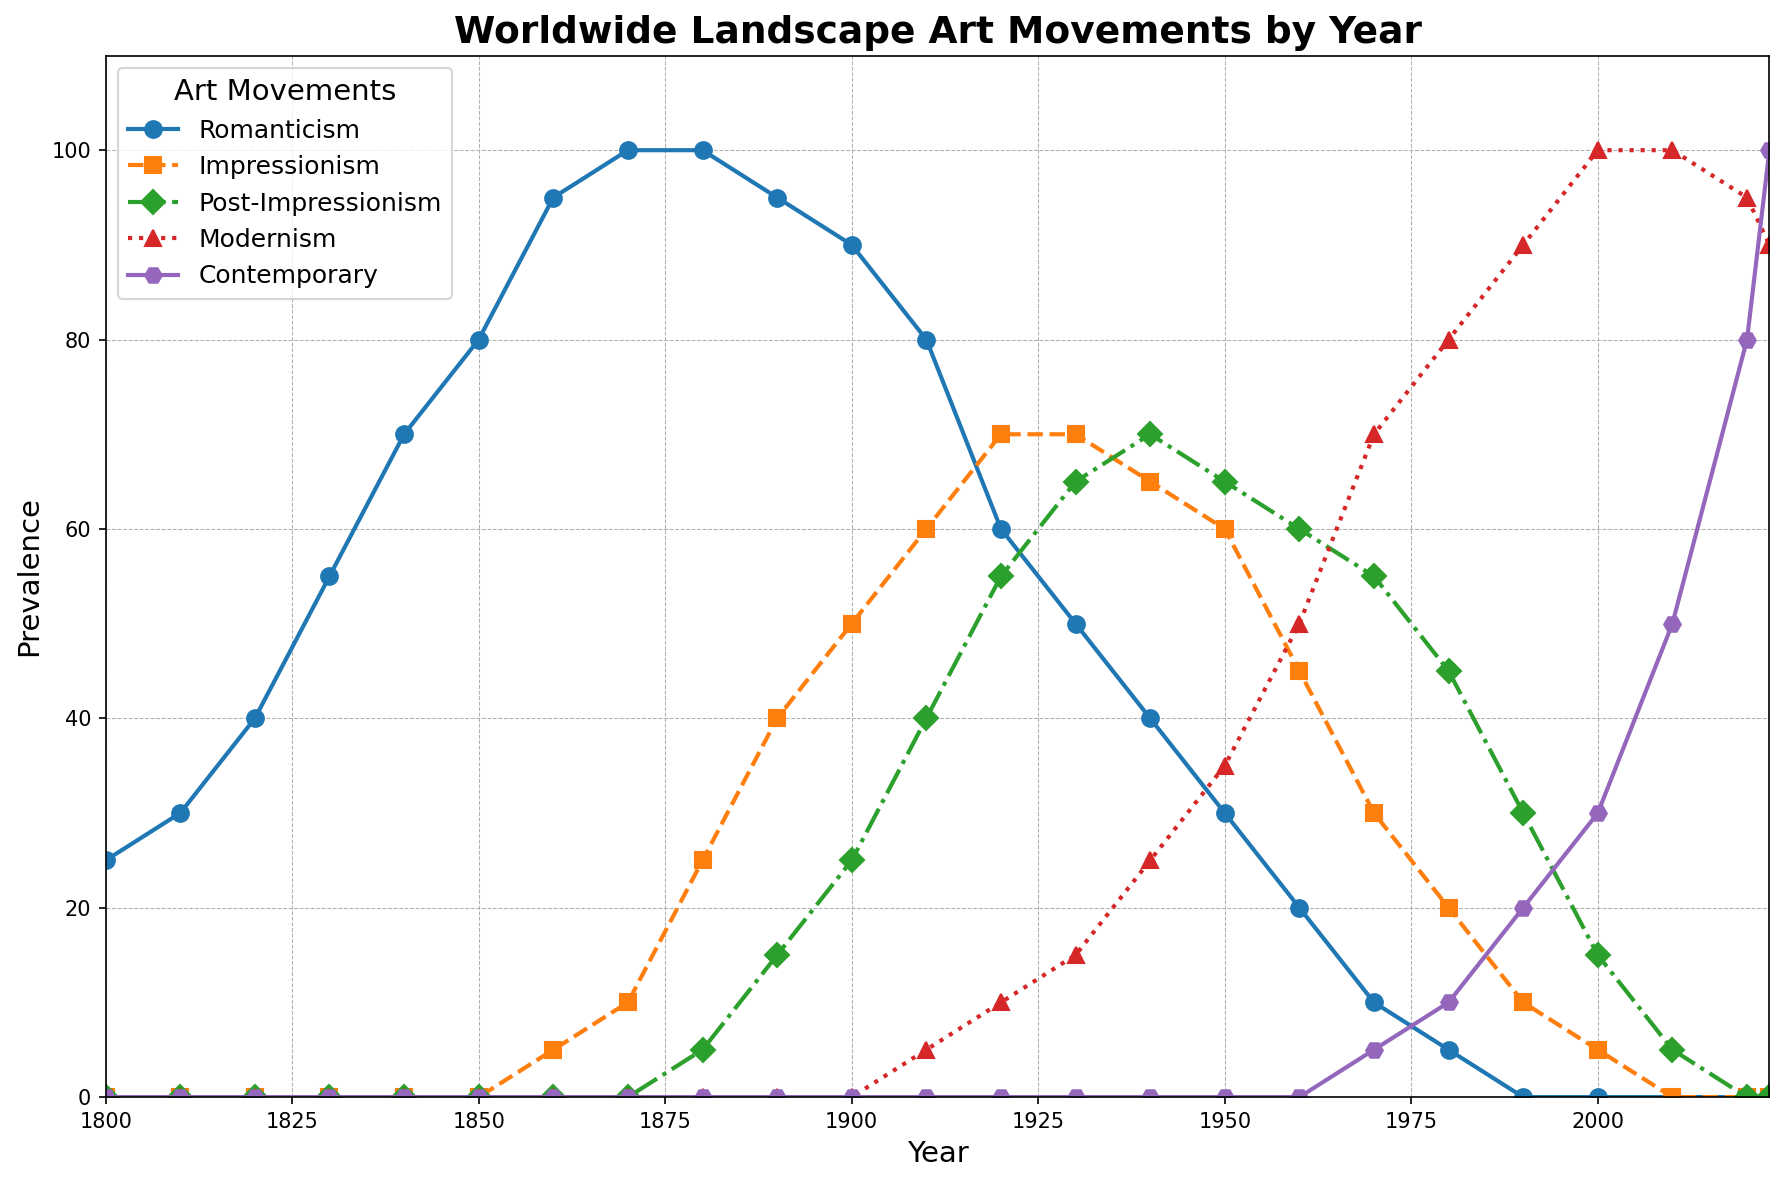What art movement was the most prevalent in 1850? The figure shows different art movements over time from 1800 to 2023, with corresponding values. For 1850, the line representing Romanticism peaks at 80. Hence, Romanticism was the most prevalent in 1850.
Answer: Romanticism Which art movement became dominant after 2000? The chart's lines can illustrate changes in dominance. Starting from 2000, Modernism shows significant growth, reaching the highest prevalence in the final years.
Answer: Modernism When did Contemporary art reach 100% prevalence? Locate the point where the line for Contemporary art hits 100% prevalence. According to the chart, this occurs in the year 2023.
Answer: 2023 Between 1830 and 1840, how did Romanticism's prevalence change? Look at the values for Romanticism in those years: 55 in 1830 and 70 in 1840. Calculate the difference.
Answer: Increased by 15 Which two art movements have equal prevalence around 1950? Around 1950, observe the lines to see if any intersect. The chart shows that Post-Impressionism and Modernism both have a prevalence of around 65 in 1950.
Answer: Post-Impressionism and Modernism How did Impressionism change from 1900 to 1920? Trace the Impressionism line from 1900 (50) to 1920 (70). The chart depicts an increase from 50 to 70.
Answer: Increased by 20 What was the prevalence of Post-Impressionism in 1980? Find the point on the chart where the Post-Impressionism line aligns with 1980. The value shown is 45.
Answer: 45 In which year did Romanticism cease to be the dominant art movement? Examine the chart to see when the Romanticism line drops below others. This occurs around 1910, when Impressionism becomes more dominant.
Answer: Around 1910 When did Modernism overtake Post-Impressionism in prevalence? Note the crossover point between the Modernism and Post-Impressionism lines. This happens around 1970-1980.
Answer: Around 1970-1980 What is the general trend in Contemporary art's prevalence from 2000 onward? Follow the Contemporary art line from 2000 onward. The line steadily rises, indicating an increase.
Answer: Increasing 